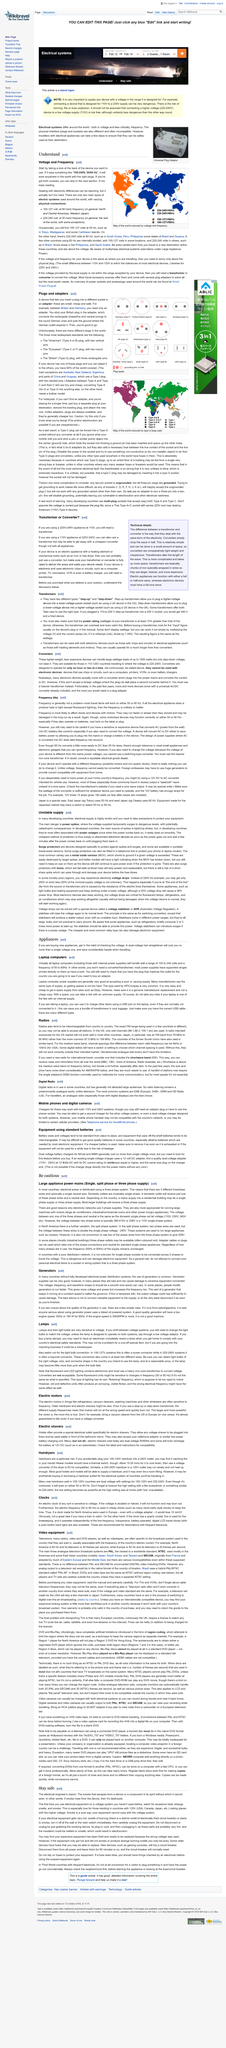Mention a couple of crucial points in this snapshot. Domestic outlets do not have a three phase supply but are always single phase. This product is capable of functioning with a voltage range of 100-240V and a frequency of 50/60Hz, making it compatible with electrical outlets found throughout the world, as long as the proper plugs are used. An adapter is a device designed to enable the insertion of a plug into a different socket, thereby allowing for the connection of electronic devices to power sources with incompatible electrical configurations. The title of this page is "Hairdryers" as indicated by the text that appears at the top of the page. There are two main types of electric systems that are used in the world: the alternating current (AC) system and the direct current (DC) system. 